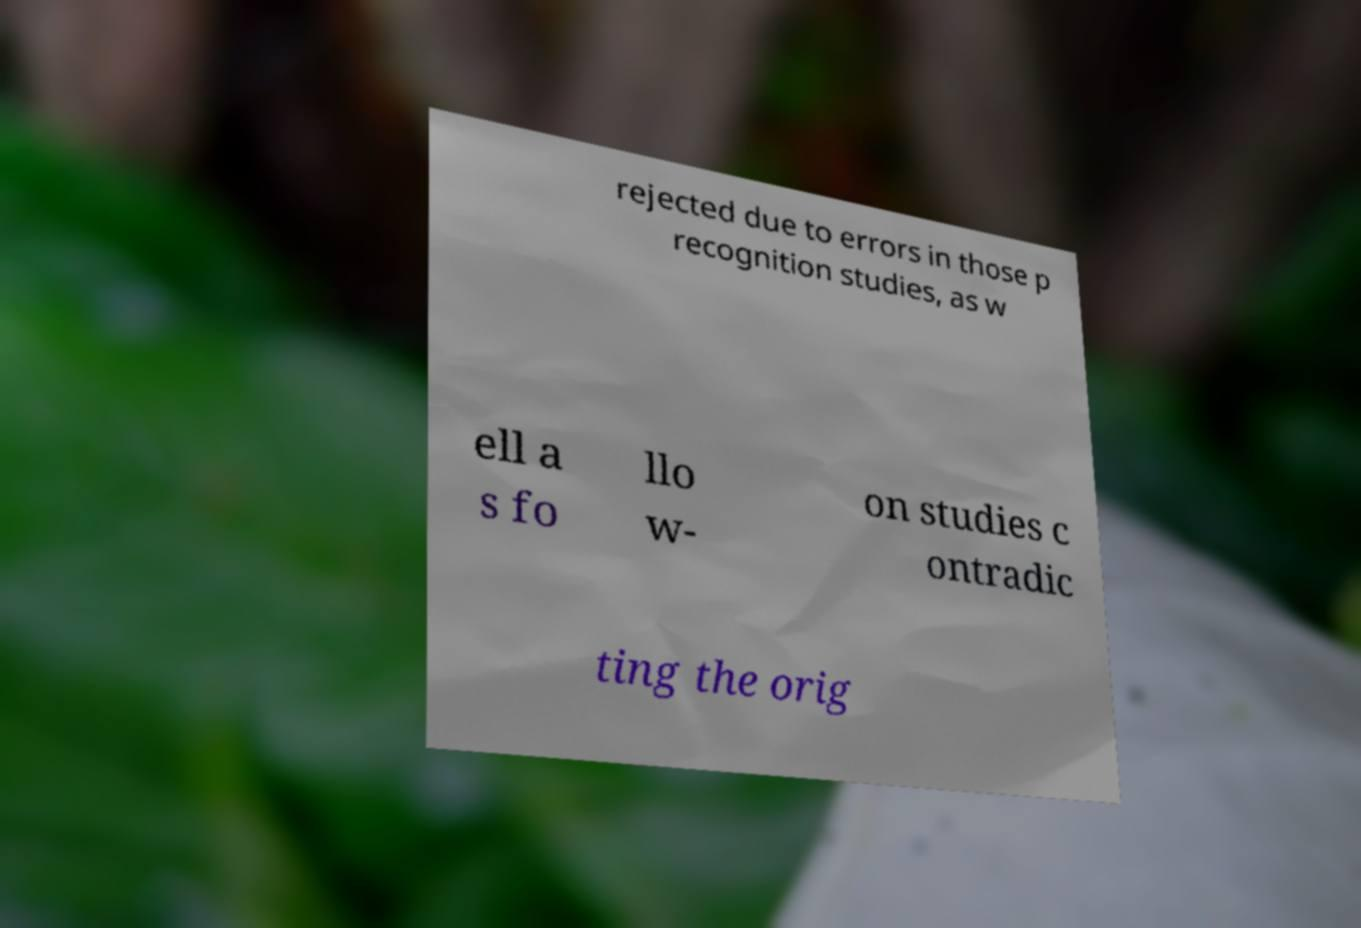For documentation purposes, I need the text within this image transcribed. Could you provide that? rejected due to errors in those p recognition studies, as w ell a s fo llo w- on studies c ontradic ting the orig 